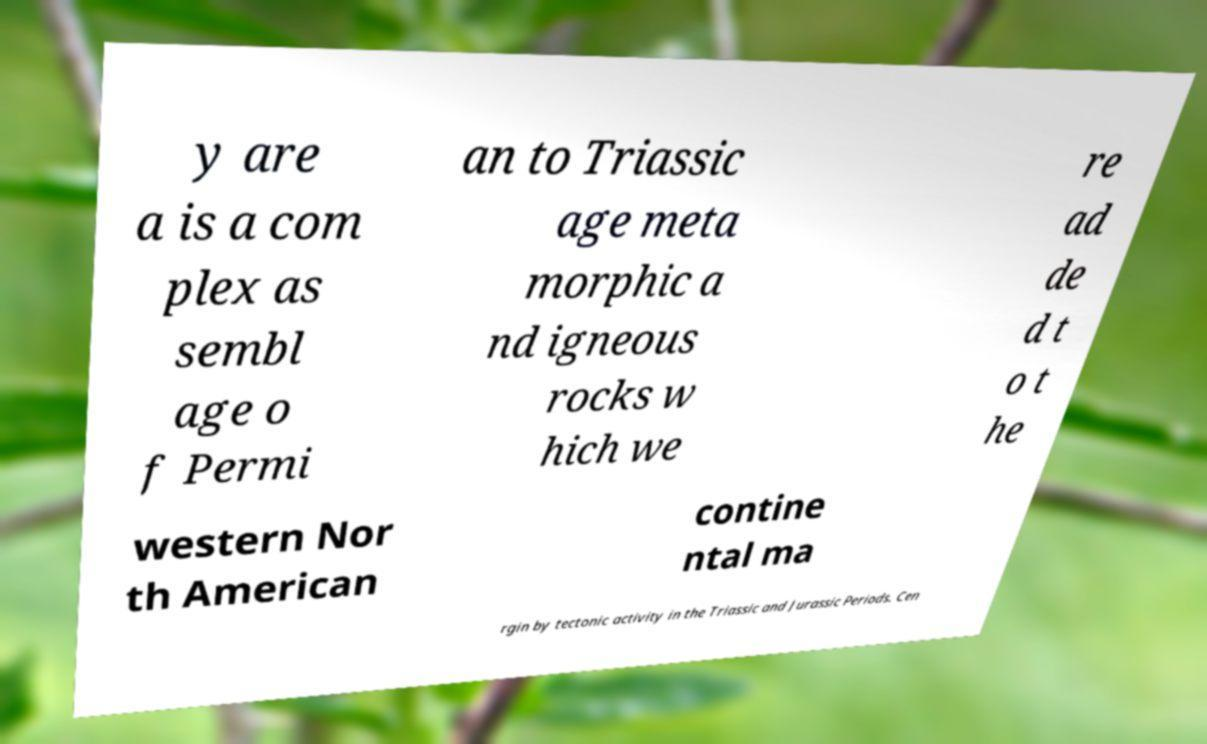For documentation purposes, I need the text within this image transcribed. Could you provide that? y are a is a com plex as sembl age o f Permi an to Triassic age meta morphic a nd igneous rocks w hich we re ad de d t o t he western Nor th American contine ntal ma rgin by tectonic activity in the Triassic and Jurassic Periods. Cen 